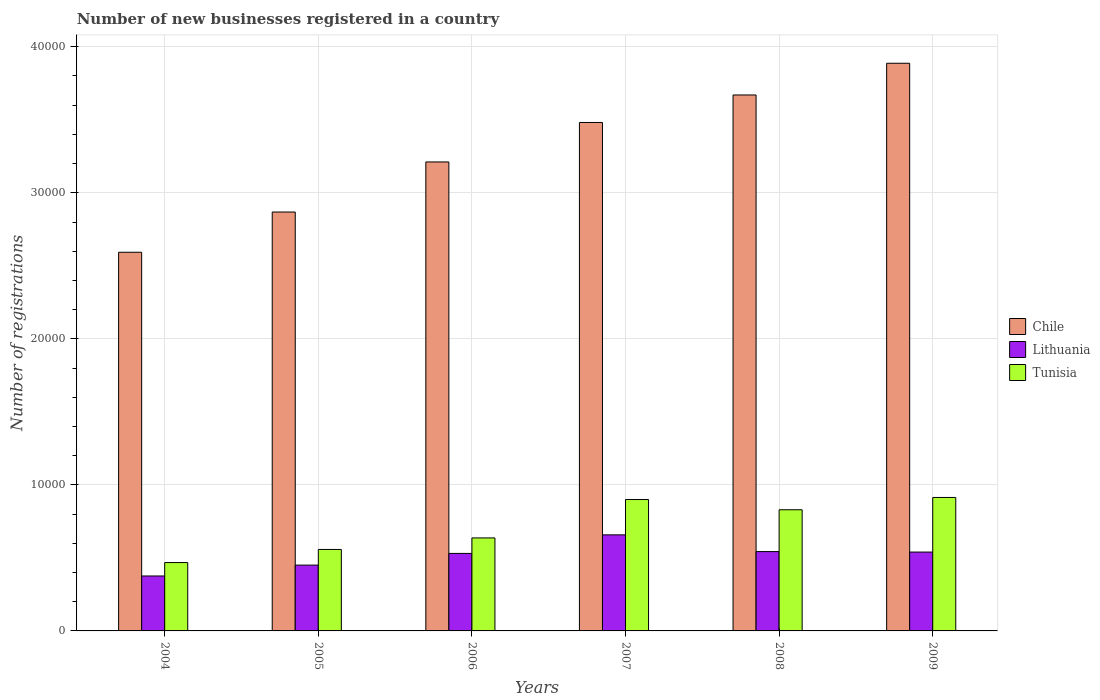How many different coloured bars are there?
Your response must be concise. 3. How many groups of bars are there?
Your response must be concise. 6. Are the number of bars per tick equal to the number of legend labels?
Provide a succinct answer. Yes. Are the number of bars on each tick of the X-axis equal?
Keep it short and to the point. Yes. What is the number of new businesses registered in Tunisia in 2007?
Your response must be concise. 8997. Across all years, what is the maximum number of new businesses registered in Tunisia?
Provide a short and direct response. 9138. Across all years, what is the minimum number of new businesses registered in Chile?
Your response must be concise. 2.59e+04. In which year was the number of new businesses registered in Chile maximum?
Ensure brevity in your answer.  2009. In which year was the number of new businesses registered in Chile minimum?
Your response must be concise. 2004. What is the total number of new businesses registered in Chile in the graph?
Your response must be concise. 1.97e+05. What is the difference between the number of new businesses registered in Lithuania in 2004 and that in 2007?
Your response must be concise. -2816. What is the difference between the number of new businesses registered in Lithuania in 2007 and the number of new businesses registered in Chile in 2006?
Give a very brief answer. -2.55e+04. What is the average number of new businesses registered in Tunisia per year?
Your answer should be very brief. 7176.33. In the year 2006, what is the difference between the number of new businesses registered in Tunisia and number of new businesses registered in Lithuania?
Your response must be concise. 1061. In how many years, is the number of new businesses registered in Chile greater than 16000?
Provide a succinct answer. 6. What is the ratio of the number of new businesses registered in Tunisia in 2004 to that in 2009?
Make the answer very short. 0.51. What is the difference between the highest and the second highest number of new businesses registered in Lithuania?
Keep it short and to the point. 1146. What is the difference between the highest and the lowest number of new businesses registered in Lithuania?
Ensure brevity in your answer.  2816. Is the sum of the number of new businesses registered in Tunisia in 2006 and 2009 greater than the maximum number of new businesses registered in Chile across all years?
Provide a succinct answer. No. What does the 2nd bar from the left in 2006 represents?
Your answer should be very brief. Lithuania. What does the 2nd bar from the right in 2004 represents?
Your answer should be very brief. Lithuania. Are all the bars in the graph horizontal?
Make the answer very short. No. How many years are there in the graph?
Your answer should be compact. 6. What is the difference between two consecutive major ticks on the Y-axis?
Your answer should be very brief. 10000. Does the graph contain any zero values?
Give a very brief answer. No. Does the graph contain grids?
Give a very brief answer. Yes. Where does the legend appear in the graph?
Give a very brief answer. Center right. What is the title of the graph?
Give a very brief answer. Number of new businesses registered in a country. What is the label or title of the Y-axis?
Keep it short and to the point. Number of registrations. What is the Number of registrations of Chile in 2004?
Your answer should be compact. 2.59e+04. What is the Number of registrations of Lithuania in 2004?
Give a very brief answer. 3762. What is the Number of registrations of Tunisia in 2004?
Your answer should be compact. 4680. What is the Number of registrations in Chile in 2005?
Offer a terse response. 2.87e+04. What is the Number of registrations of Lithuania in 2005?
Offer a terse response. 4507. What is the Number of registrations of Tunisia in 2005?
Your answer should be very brief. 5578. What is the Number of registrations of Chile in 2006?
Ensure brevity in your answer.  3.21e+04. What is the Number of registrations of Lithuania in 2006?
Provide a short and direct response. 5307. What is the Number of registrations in Tunisia in 2006?
Make the answer very short. 6368. What is the Number of registrations of Chile in 2007?
Keep it short and to the point. 3.48e+04. What is the Number of registrations of Lithuania in 2007?
Give a very brief answer. 6578. What is the Number of registrations in Tunisia in 2007?
Offer a very short reply. 8997. What is the Number of registrations in Chile in 2008?
Ensure brevity in your answer.  3.67e+04. What is the Number of registrations of Lithuania in 2008?
Your answer should be very brief. 5432. What is the Number of registrations of Tunisia in 2008?
Keep it short and to the point. 8297. What is the Number of registrations of Chile in 2009?
Ensure brevity in your answer.  3.89e+04. What is the Number of registrations in Lithuania in 2009?
Offer a terse response. 5399. What is the Number of registrations of Tunisia in 2009?
Your answer should be very brief. 9138. Across all years, what is the maximum Number of registrations in Chile?
Your answer should be compact. 3.89e+04. Across all years, what is the maximum Number of registrations of Lithuania?
Your response must be concise. 6578. Across all years, what is the maximum Number of registrations of Tunisia?
Offer a very short reply. 9138. Across all years, what is the minimum Number of registrations in Chile?
Offer a terse response. 2.59e+04. Across all years, what is the minimum Number of registrations of Lithuania?
Ensure brevity in your answer.  3762. Across all years, what is the minimum Number of registrations of Tunisia?
Offer a terse response. 4680. What is the total Number of registrations of Chile in the graph?
Your response must be concise. 1.97e+05. What is the total Number of registrations of Lithuania in the graph?
Your answer should be very brief. 3.10e+04. What is the total Number of registrations of Tunisia in the graph?
Offer a very short reply. 4.31e+04. What is the difference between the Number of registrations in Chile in 2004 and that in 2005?
Your answer should be very brief. -2756. What is the difference between the Number of registrations in Lithuania in 2004 and that in 2005?
Give a very brief answer. -745. What is the difference between the Number of registrations in Tunisia in 2004 and that in 2005?
Offer a very short reply. -898. What is the difference between the Number of registrations of Chile in 2004 and that in 2006?
Provide a succinct answer. -6184. What is the difference between the Number of registrations in Lithuania in 2004 and that in 2006?
Offer a very short reply. -1545. What is the difference between the Number of registrations of Tunisia in 2004 and that in 2006?
Your response must be concise. -1688. What is the difference between the Number of registrations of Chile in 2004 and that in 2007?
Your answer should be compact. -8887. What is the difference between the Number of registrations of Lithuania in 2004 and that in 2007?
Your response must be concise. -2816. What is the difference between the Number of registrations of Tunisia in 2004 and that in 2007?
Ensure brevity in your answer.  -4317. What is the difference between the Number of registrations of Chile in 2004 and that in 2008?
Provide a short and direct response. -1.08e+04. What is the difference between the Number of registrations in Lithuania in 2004 and that in 2008?
Give a very brief answer. -1670. What is the difference between the Number of registrations in Tunisia in 2004 and that in 2008?
Give a very brief answer. -3617. What is the difference between the Number of registrations of Chile in 2004 and that in 2009?
Offer a terse response. -1.29e+04. What is the difference between the Number of registrations in Lithuania in 2004 and that in 2009?
Your answer should be compact. -1637. What is the difference between the Number of registrations of Tunisia in 2004 and that in 2009?
Offer a very short reply. -4458. What is the difference between the Number of registrations of Chile in 2005 and that in 2006?
Offer a terse response. -3428. What is the difference between the Number of registrations in Lithuania in 2005 and that in 2006?
Your response must be concise. -800. What is the difference between the Number of registrations of Tunisia in 2005 and that in 2006?
Your answer should be very brief. -790. What is the difference between the Number of registrations of Chile in 2005 and that in 2007?
Make the answer very short. -6131. What is the difference between the Number of registrations in Lithuania in 2005 and that in 2007?
Your answer should be compact. -2071. What is the difference between the Number of registrations in Tunisia in 2005 and that in 2007?
Your response must be concise. -3419. What is the difference between the Number of registrations of Chile in 2005 and that in 2008?
Give a very brief answer. -8014. What is the difference between the Number of registrations in Lithuania in 2005 and that in 2008?
Provide a succinct answer. -925. What is the difference between the Number of registrations of Tunisia in 2005 and that in 2008?
Offer a terse response. -2719. What is the difference between the Number of registrations in Chile in 2005 and that in 2009?
Offer a very short reply. -1.02e+04. What is the difference between the Number of registrations in Lithuania in 2005 and that in 2009?
Your response must be concise. -892. What is the difference between the Number of registrations of Tunisia in 2005 and that in 2009?
Give a very brief answer. -3560. What is the difference between the Number of registrations of Chile in 2006 and that in 2007?
Provide a short and direct response. -2703. What is the difference between the Number of registrations of Lithuania in 2006 and that in 2007?
Your response must be concise. -1271. What is the difference between the Number of registrations of Tunisia in 2006 and that in 2007?
Provide a succinct answer. -2629. What is the difference between the Number of registrations of Chile in 2006 and that in 2008?
Your answer should be compact. -4586. What is the difference between the Number of registrations in Lithuania in 2006 and that in 2008?
Your response must be concise. -125. What is the difference between the Number of registrations of Tunisia in 2006 and that in 2008?
Offer a terse response. -1929. What is the difference between the Number of registrations in Chile in 2006 and that in 2009?
Your response must be concise. -6758. What is the difference between the Number of registrations in Lithuania in 2006 and that in 2009?
Offer a terse response. -92. What is the difference between the Number of registrations in Tunisia in 2006 and that in 2009?
Provide a succinct answer. -2770. What is the difference between the Number of registrations in Chile in 2007 and that in 2008?
Offer a terse response. -1883. What is the difference between the Number of registrations of Lithuania in 2007 and that in 2008?
Provide a short and direct response. 1146. What is the difference between the Number of registrations of Tunisia in 2007 and that in 2008?
Provide a short and direct response. 700. What is the difference between the Number of registrations in Chile in 2007 and that in 2009?
Provide a short and direct response. -4055. What is the difference between the Number of registrations of Lithuania in 2007 and that in 2009?
Ensure brevity in your answer.  1179. What is the difference between the Number of registrations of Tunisia in 2007 and that in 2009?
Your answer should be compact. -141. What is the difference between the Number of registrations of Chile in 2008 and that in 2009?
Give a very brief answer. -2172. What is the difference between the Number of registrations of Tunisia in 2008 and that in 2009?
Offer a very short reply. -841. What is the difference between the Number of registrations in Chile in 2004 and the Number of registrations in Lithuania in 2005?
Offer a very short reply. 2.14e+04. What is the difference between the Number of registrations in Chile in 2004 and the Number of registrations in Tunisia in 2005?
Offer a very short reply. 2.04e+04. What is the difference between the Number of registrations of Lithuania in 2004 and the Number of registrations of Tunisia in 2005?
Your response must be concise. -1816. What is the difference between the Number of registrations in Chile in 2004 and the Number of registrations in Lithuania in 2006?
Ensure brevity in your answer.  2.06e+04. What is the difference between the Number of registrations in Chile in 2004 and the Number of registrations in Tunisia in 2006?
Provide a succinct answer. 1.96e+04. What is the difference between the Number of registrations of Lithuania in 2004 and the Number of registrations of Tunisia in 2006?
Ensure brevity in your answer.  -2606. What is the difference between the Number of registrations of Chile in 2004 and the Number of registrations of Lithuania in 2007?
Give a very brief answer. 1.94e+04. What is the difference between the Number of registrations in Chile in 2004 and the Number of registrations in Tunisia in 2007?
Keep it short and to the point. 1.69e+04. What is the difference between the Number of registrations of Lithuania in 2004 and the Number of registrations of Tunisia in 2007?
Your response must be concise. -5235. What is the difference between the Number of registrations in Chile in 2004 and the Number of registrations in Lithuania in 2008?
Ensure brevity in your answer.  2.05e+04. What is the difference between the Number of registrations in Chile in 2004 and the Number of registrations in Tunisia in 2008?
Offer a terse response. 1.76e+04. What is the difference between the Number of registrations in Lithuania in 2004 and the Number of registrations in Tunisia in 2008?
Make the answer very short. -4535. What is the difference between the Number of registrations of Chile in 2004 and the Number of registrations of Lithuania in 2009?
Your answer should be compact. 2.05e+04. What is the difference between the Number of registrations in Chile in 2004 and the Number of registrations in Tunisia in 2009?
Your response must be concise. 1.68e+04. What is the difference between the Number of registrations in Lithuania in 2004 and the Number of registrations in Tunisia in 2009?
Make the answer very short. -5376. What is the difference between the Number of registrations in Chile in 2005 and the Number of registrations in Lithuania in 2006?
Provide a succinct answer. 2.34e+04. What is the difference between the Number of registrations of Chile in 2005 and the Number of registrations of Tunisia in 2006?
Make the answer very short. 2.23e+04. What is the difference between the Number of registrations of Lithuania in 2005 and the Number of registrations of Tunisia in 2006?
Your answer should be compact. -1861. What is the difference between the Number of registrations of Chile in 2005 and the Number of registrations of Lithuania in 2007?
Offer a terse response. 2.21e+04. What is the difference between the Number of registrations in Chile in 2005 and the Number of registrations in Tunisia in 2007?
Your answer should be very brief. 1.97e+04. What is the difference between the Number of registrations in Lithuania in 2005 and the Number of registrations in Tunisia in 2007?
Offer a very short reply. -4490. What is the difference between the Number of registrations of Chile in 2005 and the Number of registrations of Lithuania in 2008?
Your response must be concise. 2.33e+04. What is the difference between the Number of registrations of Chile in 2005 and the Number of registrations of Tunisia in 2008?
Give a very brief answer. 2.04e+04. What is the difference between the Number of registrations in Lithuania in 2005 and the Number of registrations in Tunisia in 2008?
Make the answer very short. -3790. What is the difference between the Number of registrations of Chile in 2005 and the Number of registrations of Lithuania in 2009?
Make the answer very short. 2.33e+04. What is the difference between the Number of registrations in Chile in 2005 and the Number of registrations in Tunisia in 2009?
Offer a terse response. 1.95e+04. What is the difference between the Number of registrations in Lithuania in 2005 and the Number of registrations in Tunisia in 2009?
Give a very brief answer. -4631. What is the difference between the Number of registrations in Chile in 2006 and the Number of registrations in Lithuania in 2007?
Give a very brief answer. 2.55e+04. What is the difference between the Number of registrations in Chile in 2006 and the Number of registrations in Tunisia in 2007?
Give a very brief answer. 2.31e+04. What is the difference between the Number of registrations of Lithuania in 2006 and the Number of registrations of Tunisia in 2007?
Offer a terse response. -3690. What is the difference between the Number of registrations in Chile in 2006 and the Number of registrations in Lithuania in 2008?
Offer a terse response. 2.67e+04. What is the difference between the Number of registrations in Chile in 2006 and the Number of registrations in Tunisia in 2008?
Your response must be concise. 2.38e+04. What is the difference between the Number of registrations in Lithuania in 2006 and the Number of registrations in Tunisia in 2008?
Make the answer very short. -2990. What is the difference between the Number of registrations in Chile in 2006 and the Number of registrations in Lithuania in 2009?
Your response must be concise. 2.67e+04. What is the difference between the Number of registrations of Chile in 2006 and the Number of registrations of Tunisia in 2009?
Ensure brevity in your answer.  2.30e+04. What is the difference between the Number of registrations of Lithuania in 2006 and the Number of registrations of Tunisia in 2009?
Provide a succinct answer. -3831. What is the difference between the Number of registrations in Chile in 2007 and the Number of registrations in Lithuania in 2008?
Keep it short and to the point. 2.94e+04. What is the difference between the Number of registrations in Chile in 2007 and the Number of registrations in Tunisia in 2008?
Your answer should be very brief. 2.65e+04. What is the difference between the Number of registrations of Lithuania in 2007 and the Number of registrations of Tunisia in 2008?
Keep it short and to the point. -1719. What is the difference between the Number of registrations in Chile in 2007 and the Number of registrations in Lithuania in 2009?
Ensure brevity in your answer.  2.94e+04. What is the difference between the Number of registrations of Chile in 2007 and the Number of registrations of Tunisia in 2009?
Your answer should be compact. 2.57e+04. What is the difference between the Number of registrations of Lithuania in 2007 and the Number of registrations of Tunisia in 2009?
Ensure brevity in your answer.  -2560. What is the difference between the Number of registrations of Chile in 2008 and the Number of registrations of Lithuania in 2009?
Offer a very short reply. 3.13e+04. What is the difference between the Number of registrations of Chile in 2008 and the Number of registrations of Tunisia in 2009?
Ensure brevity in your answer.  2.76e+04. What is the difference between the Number of registrations of Lithuania in 2008 and the Number of registrations of Tunisia in 2009?
Offer a terse response. -3706. What is the average Number of registrations of Chile per year?
Offer a terse response. 3.29e+04. What is the average Number of registrations in Lithuania per year?
Your response must be concise. 5164.17. What is the average Number of registrations of Tunisia per year?
Keep it short and to the point. 7176.33. In the year 2004, what is the difference between the Number of registrations in Chile and Number of registrations in Lithuania?
Your response must be concise. 2.22e+04. In the year 2004, what is the difference between the Number of registrations of Chile and Number of registrations of Tunisia?
Keep it short and to the point. 2.12e+04. In the year 2004, what is the difference between the Number of registrations in Lithuania and Number of registrations in Tunisia?
Your response must be concise. -918. In the year 2005, what is the difference between the Number of registrations of Chile and Number of registrations of Lithuania?
Give a very brief answer. 2.42e+04. In the year 2005, what is the difference between the Number of registrations of Chile and Number of registrations of Tunisia?
Provide a succinct answer. 2.31e+04. In the year 2005, what is the difference between the Number of registrations in Lithuania and Number of registrations in Tunisia?
Offer a very short reply. -1071. In the year 2006, what is the difference between the Number of registrations in Chile and Number of registrations in Lithuania?
Give a very brief answer. 2.68e+04. In the year 2006, what is the difference between the Number of registrations in Chile and Number of registrations in Tunisia?
Offer a terse response. 2.57e+04. In the year 2006, what is the difference between the Number of registrations in Lithuania and Number of registrations in Tunisia?
Your response must be concise. -1061. In the year 2007, what is the difference between the Number of registrations of Chile and Number of registrations of Lithuania?
Provide a short and direct response. 2.82e+04. In the year 2007, what is the difference between the Number of registrations in Chile and Number of registrations in Tunisia?
Provide a succinct answer. 2.58e+04. In the year 2007, what is the difference between the Number of registrations in Lithuania and Number of registrations in Tunisia?
Your answer should be compact. -2419. In the year 2008, what is the difference between the Number of registrations of Chile and Number of registrations of Lithuania?
Your answer should be compact. 3.13e+04. In the year 2008, what is the difference between the Number of registrations of Chile and Number of registrations of Tunisia?
Offer a very short reply. 2.84e+04. In the year 2008, what is the difference between the Number of registrations of Lithuania and Number of registrations of Tunisia?
Your response must be concise. -2865. In the year 2009, what is the difference between the Number of registrations in Chile and Number of registrations in Lithuania?
Ensure brevity in your answer.  3.35e+04. In the year 2009, what is the difference between the Number of registrations of Chile and Number of registrations of Tunisia?
Offer a very short reply. 2.97e+04. In the year 2009, what is the difference between the Number of registrations of Lithuania and Number of registrations of Tunisia?
Make the answer very short. -3739. What is the ratio of the Number of registrations in Chile in 2004 to that in 2005?
Keep it short and to the point. 0.9. What is the ratio of the Number of registrations in Lithuania in 2004 to that in 2005?
Make the answer very short. 0.83. What is the ratio of the Number of registrations of Tunisia in 2004 to that in 2005?
Your response must be concise. 0.84. What is the ratio of the Number of registrations in Chile in 2004 to that in 2006?
Provide a short and direct response. 0.81. What is the ratio of the Number of registrations in Lithuania in 2004 to that in 2006?
Your answer should be very brief. 0.71. What is the ratio of the Number of registrations in Tunisia in 2004 to that in 2006?
Ensure brevity in your answer.  0.73. What is the ratio of the Number of registrations of Chile in 2004 to that in 2007?
Keep it short and to the point. 0.74. What is the ratio of the Number of registrations of Lithuania in 2004 to that in 2007?
Your answer should be very brief. 0.57. What is the ratio of the Number of registrations in Tunisia in 2004 to that in 2007?
Your answer should be very brief. 0.52. What is the ratio of the Number of registrations in Chile in 2004 to that in 2008?
Your answer should be very brief. 0.71. What is the ratio of the Number of registrations of Lithuania in 2004 to that in 2008?
Make the answer very short. 0.69. What is the ratio of the Number of registrations of Tunisia in 2004 to that in 2008?
Provide a short and direct response. 0.56. What is the ratio of the Number of registrations in Chile in 2004 to that in 2009?
Offer a very short reply. 0.67. What is the ratio of the Number of registrations in Lithuania in 2004 to that in 2009?
Your answer should be compact. 0.7. What is the ratio of the Number of registrations in Tunisia in 2004 to that in 2009?
Offer a very short reply. 0.51. What is the ratio of the Number of registrations of Chile in 2005 to that in 2006?
Offer a very short reply. 0.89. What is the ratio of the Number of registrations in Lithuania in 2005 to that in 2006?
Offer a very short reply. 0.85. What is the ratio of the Number of registrations in Tunisia in 2005 to that in 2006?
Your answer should be compact. 0.88. What is the ratio of the Number of registrations in Chile in 2005 to that in 2007?
Make the answer very short. 0.82. What is the ratio of the Number of registrations in Lithuania in 2005 to that in 2007?
Give a very brief answer. 0.69. What is the ratio of the Number of registrations of Tunisia in 2005 to that in 2007?
Ensure brevity in your answer.  0.62. What is the ratio of the Number of registrations in Chile in 2005 to that in 2008?
Offer a very short reply. 0.78. What is the ratio of the Number of registrations in Lithuania in 2005 to that in 2008?
Your answer should be very brief. 0.83. What is the ratio of the Number of registrations of Tunisia in 2005 to that in 2008?
Provide a short and direct response. 0.67. What is the ratio of the Number of registrations in Chile in 2005 to that in 2009?
Your answer should be compact. 0.74. What is the ratio of the Number of registrations of Lithuania in 2005 to that in 2009?
Your answer should be very brief. 0.83. What is the ratio of the Number of registrations of Tunisia in 2005 to that in 2009?
Your response must be concise. 0.61. What is the ratio of the Number of registrations of Chile in 2006 to that in 2007?
Provide a short and direct response. 0.92. What is the ratio of the Number of registrations in Lithuania in 2006 to that in 2007?
Your response must be concise. 0.81. What is the ratio of the Number of registrations in Tunisia in 2006 to that in 2007?
Offer a terse response. 0.71. What is the ratio of the Number of registrations in Lithuania in 2006 to that in 2008?
Offer a very short reply. 0.98. What is the ratio of the Number of registrations of Tunisia in 2006 to that in 2008?
Provide a succinct answer. 0.77. What is the ratio of the Number of registrations in Chile in 2006 to that in 2009?
Provide a short and direct response. 0.83. What is the ratio of the Number of registrations of Lithuania in 2006 to that in 2009?
Your answer should be very brief. 0.98. What is the ratio of the Number of registrations in Tunisia in 2006 to that in 2009?
Your answer should be very brief. 0.7. What is the ratio of the Number of registrations of Chile in 2007 to that in 2008?
Offer a terse response. 0.95. What is the ratio of the Number of registrations in Lithuania in 2007 to that in 2008?
Your response must be concise. 1.21. What is the ratio of the Number of registrations of Tunisia in 2007 to that in 2008?
Make the answer very short. 1.08. What is the ratio of the Number of registrations in Chile in 2007 to that in 2009?
Your response must be concise. 0.9. What is the ratio of the Number of registrations in Lithuania in 2007 to that in 2009?
Keep it short and to the point. 1.22. What is the ratio of the Number of registrations in Tunisia in 2007 to that in 2009?
Give a very brief answer. 0.98. What is the ratio of the Number of registrations in Chile in 2008 to that in 2009?
Give a very brief answer. 0.94. What is the ratio of the Number of registrations of Lithuania in 2008 to that in 2009?
Make the answer very short. 1.01. What is the ratio of the Number of registrations of Tunisia in 2008 to that in 2009?
Your answer should be very brief. 0.91. What is the difference between the highest and the second highest Number of registrations in Chile?
Make the answer very short. 2172. What is the difference between the highest and the second highest Number of registrations in Lithuania?
Ensure brevity in your answer.  1146. What is the difference between the highest and the second highest Number of registrations of Tunisia?
Keep it short and to the point. 141. What is the difference between the highest and the lowest Number of registrations in Chile?
Your response must be concise. 1.29e+04. What is the difference between the highest and the lowest Number of registrations in Lithuania?
Give a very brief answer. 2816. What is the difference between the highest and the lowest Number of registrations in Tunisia?
Your answer should be very brief. 4458. 